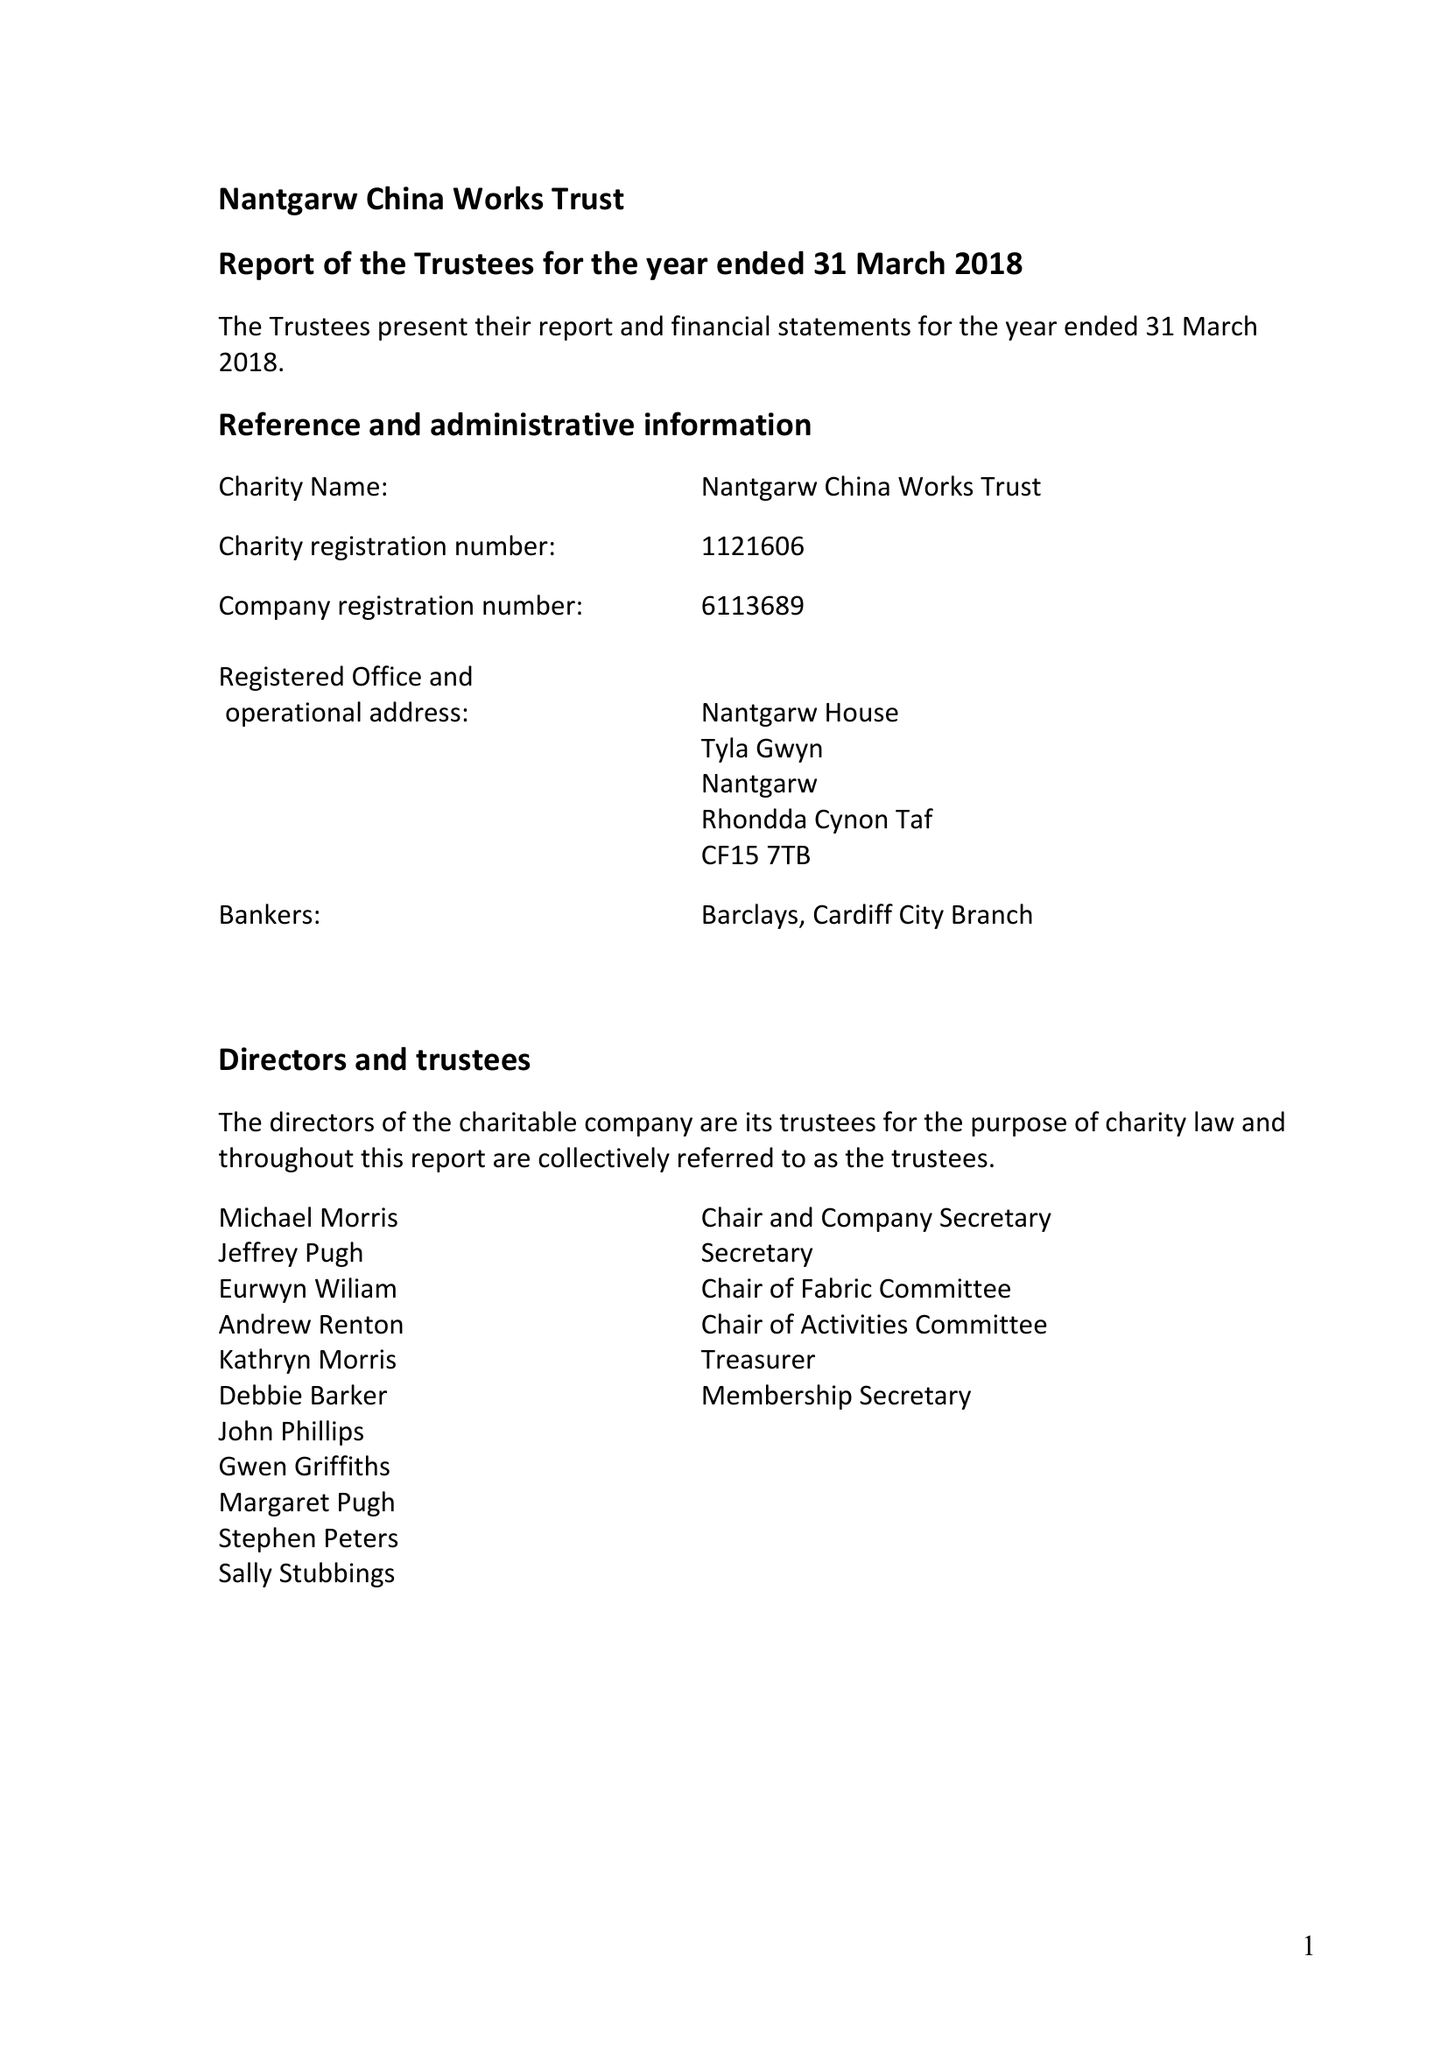What is the value for the address__postcode?
Answer the question using a single word or phrase. CF15 7TB 